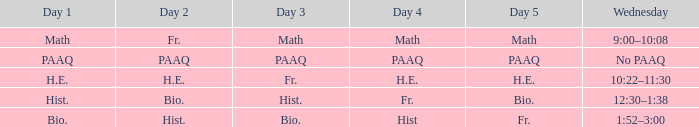When day 4 is a friday, what day would day 3 be? Hist. 